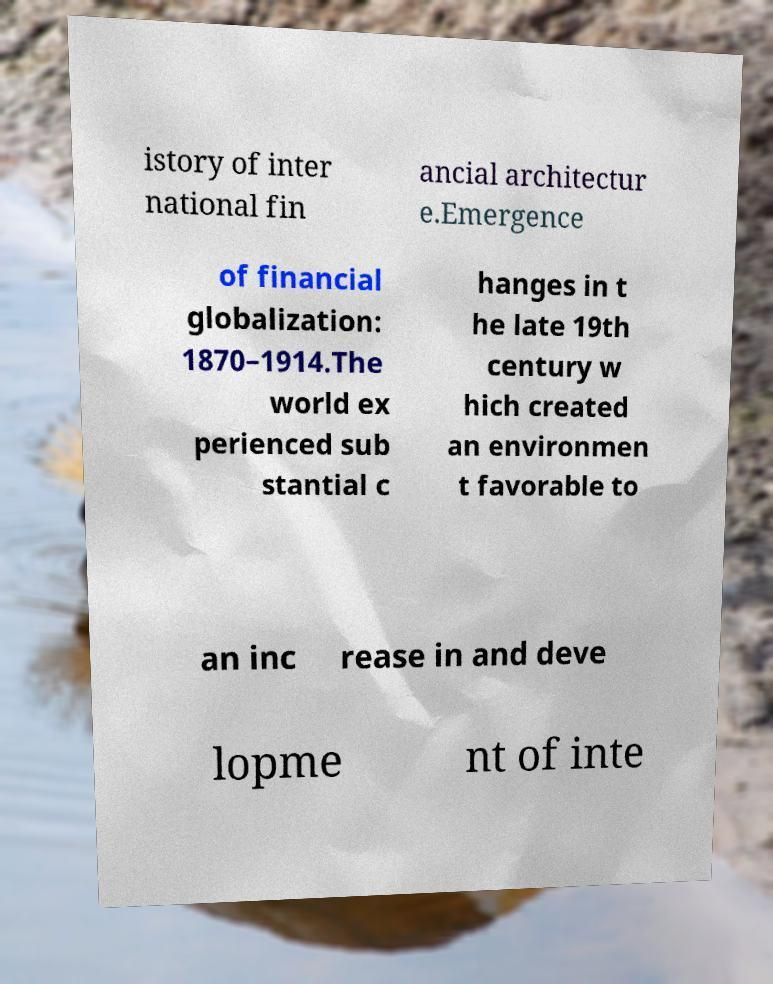Please identify and transcribe the text found in this image. istory of inter national fin ancial architectur e.Emergence of financial globalization: 1870–1914.The world ex perienced sub stantial c hanges in t he late 19th century w hich created an environmen t favorable to an inc rease in and deve lopme nt of inte 